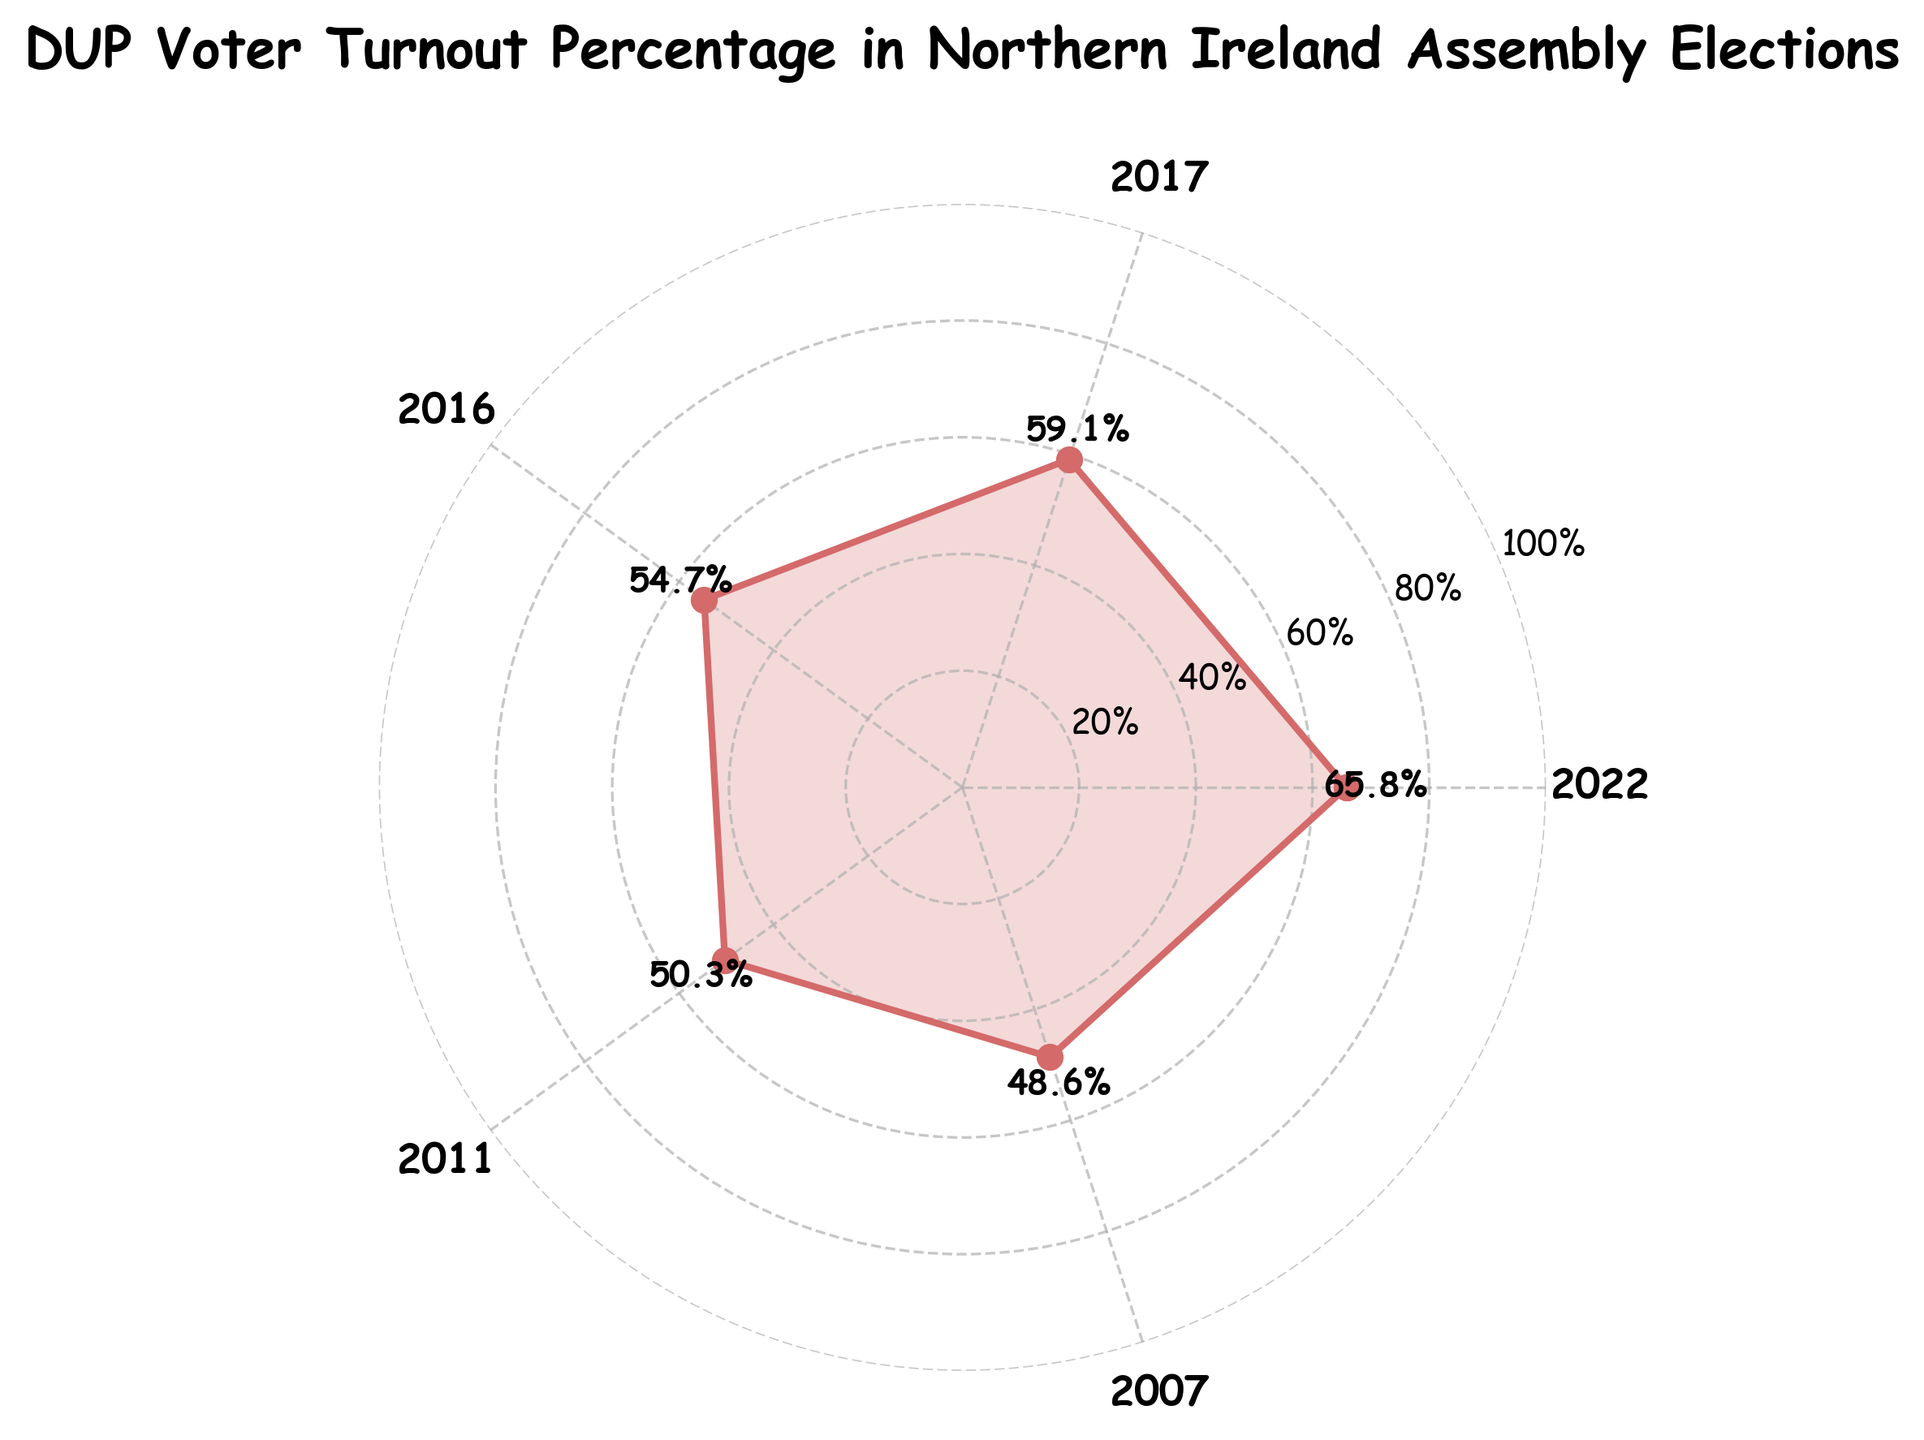What is the title of the figure? The title of the figure is usually located at the top. In this case, it's "DUP Voter Turnout Percentage in Northern Ireland Assembly Elections".
Answer: DUP Voter Turnout Percentage in Northern Ireland Assembly Elections How many election years are represented in the figure? By counting the number of labels around the plot, we can see there are 5 election years represented: 2007, 2011, 2016, 2017, and 2022.
Answer: 5 What is the voter turnout percentage for the DUP in the 2017 election? Find the label for the year 2017 on the plot and read the corresponding voter turnout percentage, which is indicated directly on the plot. It is 59.1%.
Answer: 59.1% What is the overall trend in voter turnout for the DUP from 2007 to 2022? Observing the plotted line, it starts low in 2007 and generally increases until 2022. This indicates that the overall trend in voter turnout for the DUP is increasing.
Answer: Increasing By how much did the voter turnout percentage change from 2011 to 2017? Locate the points for the years 2011 (50.3%) and 2017 (59.1%). Subtract the 2011 percentage from the 2017 percentage: 59.1% - 50.3% = 8.8%.
Answer: 8.8% Which year had the highest voter turnout for the DUP? Identify the point with the highest value on the radial axis. The year corresponding to this highest point is 2022 with a voter turnout percentage of 65.8%.
Answer: 2022 How does the voter turnout in 2016 compare to that in 2007? Locate the points for the years 2016 (54.7%) and 2007 (48.6%). The value in 2016 is higher than in 2007.
Answer: Higher What is the average voter turnout percentage for the DUP over the years represented? Sum all the voter turnout percentages (48.6 + 50.3 + 54.7 + 59.1 + 65.8 = 278.5) and divide by the number of years (5). So, the average is 278.5 / 5 = 55.7%.
Answer: 55.7% Between which consecutive years did the voter turnout percentage increase the most? Calculate the differences between consecutive years: 2011-2007 (1.7), 2016-2011 (4.4), 2017-2016 (4.4), 2022-2017 (6.7). The largest increase is 6.7 (2022-2017).
Answer: 2022-2017 What is the year with the minimum voter turnout percentage after 2010? Among the years 2011 (50.3%), 2016 (54.7%), 2017 (59.1%), and 2022 (65.8%), the minimum voter turnout percentage is 50.3% in 2011.
Answer: 2011 